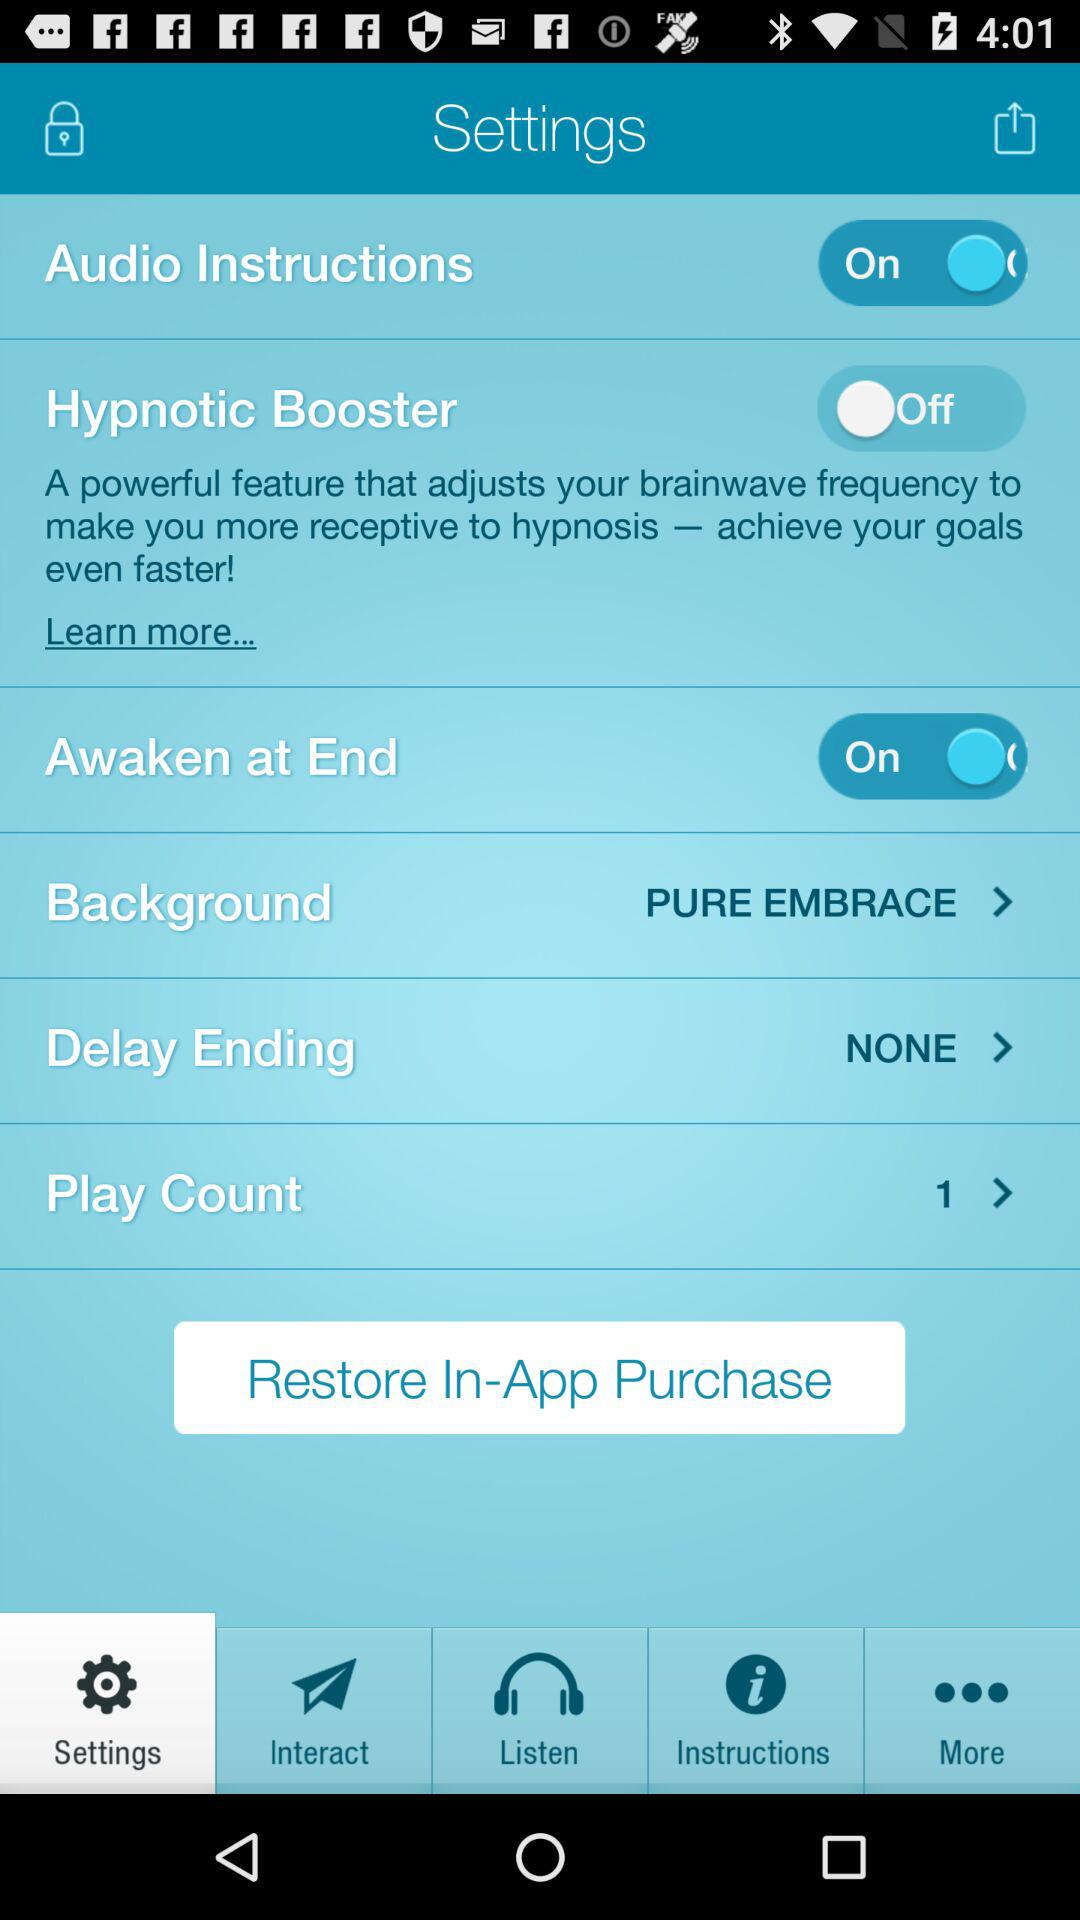What is the status of "Awaken at End"?
Answer the question using a single word or phrase. The status is"on". 